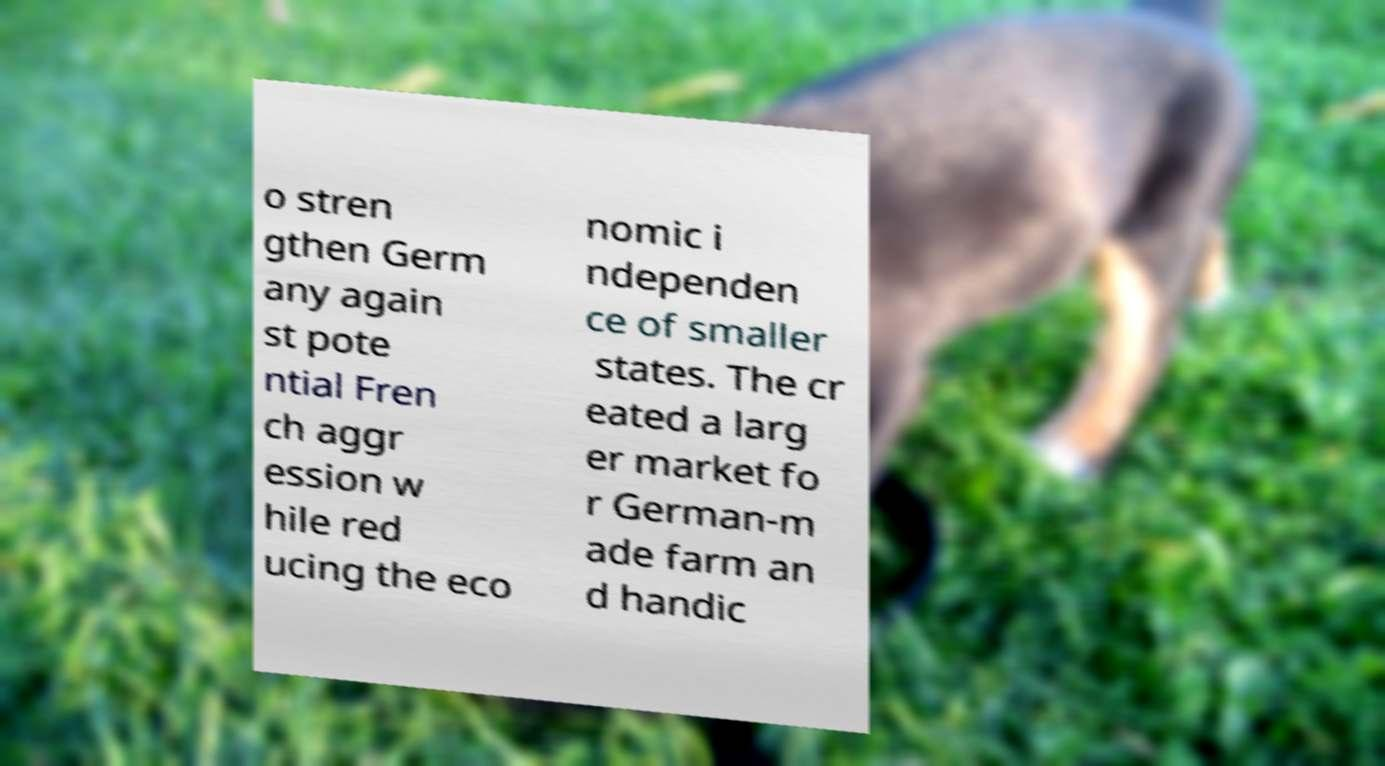Please identify and transcribe the text found in this image. o stren gthen Germ any again st pote ntial Fren ch aggr ession w hile red ucing the eco nomic i ndependen ce of smaller states. The cr eated a larg er market fo r German-m ade farm an d handic 